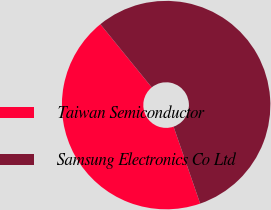Convert chart to OTSL. <chart><loc_0><loc_0><loc_500><loc_500><pie_chart><fcel>Taiwan Semiconductor<fcel>Samsung Electronics Co Ltd<nl><fcel>44.44%<fcel>55.56%<nl></chart> 